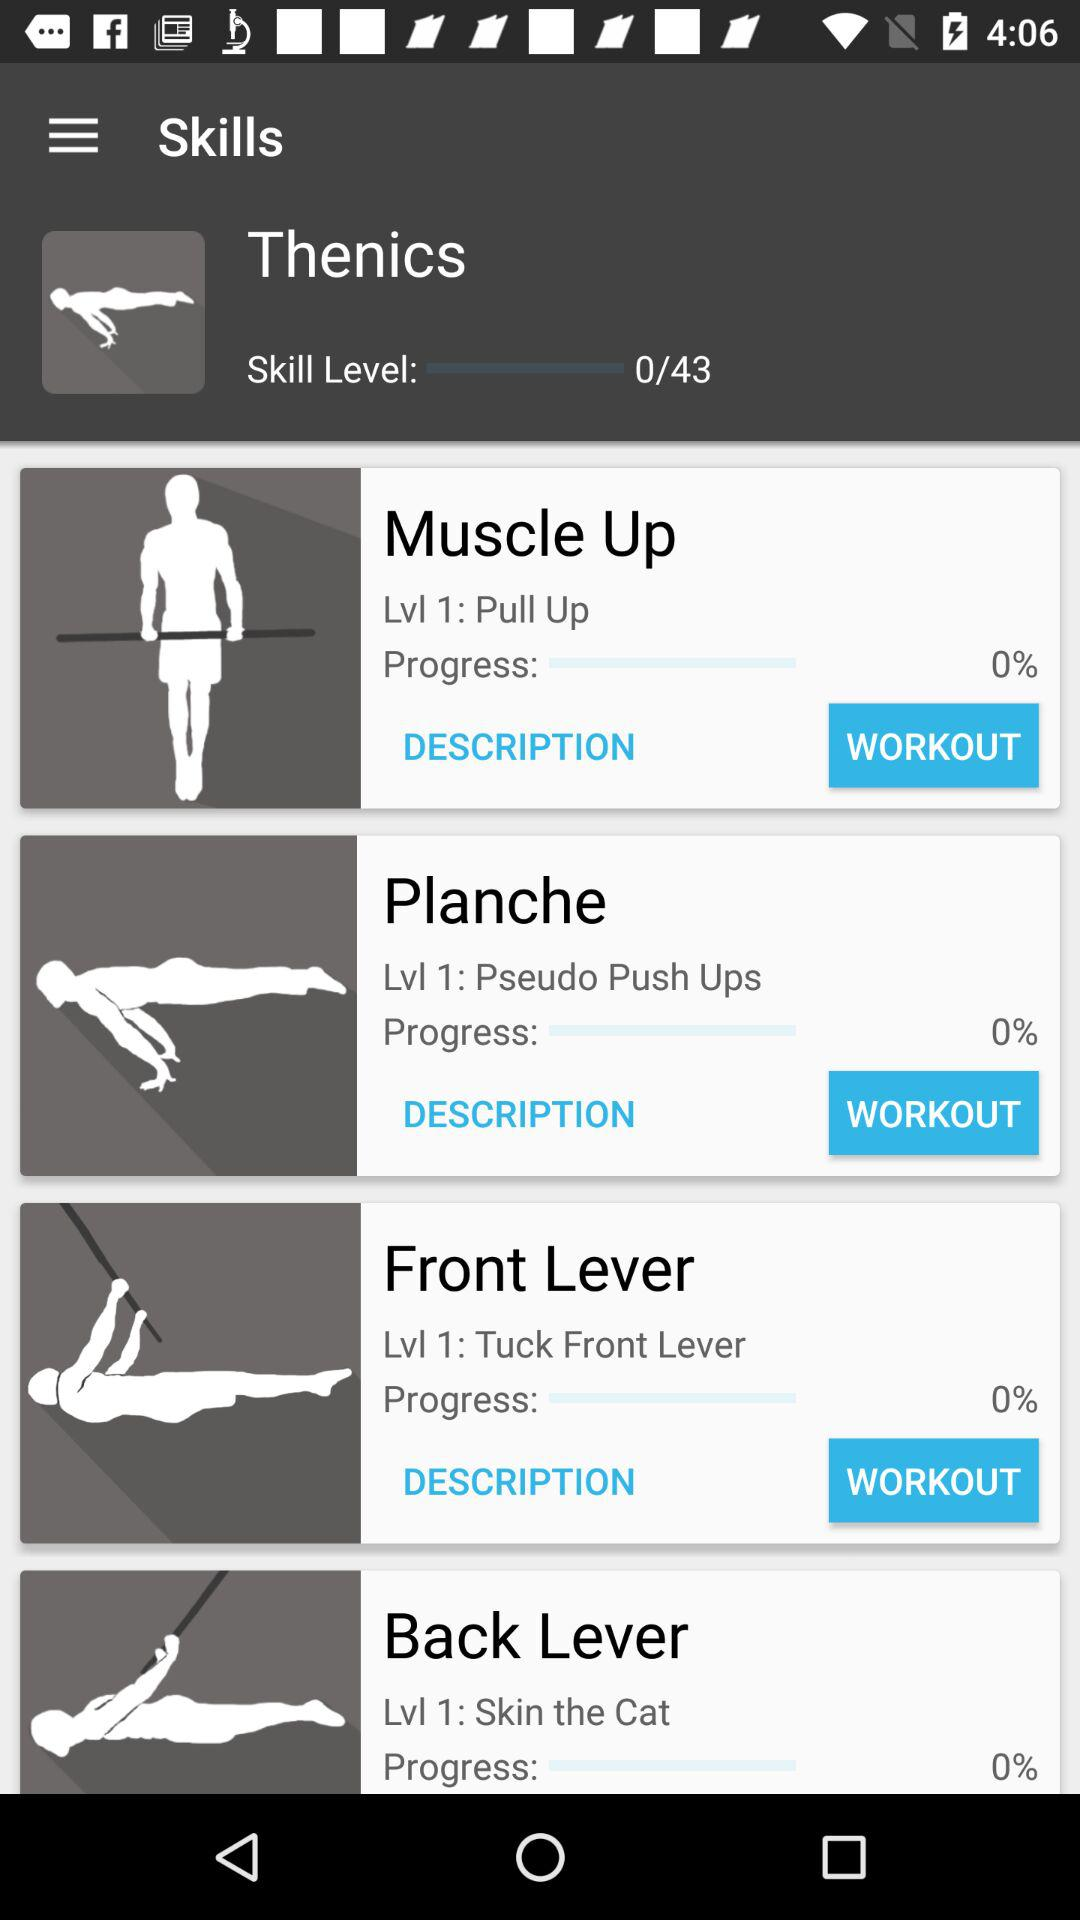How difficult is it to do a "Muscle Up" calisthenic exercise?
When the provided information is insufficient, respond with <no answer>. <no answer> 